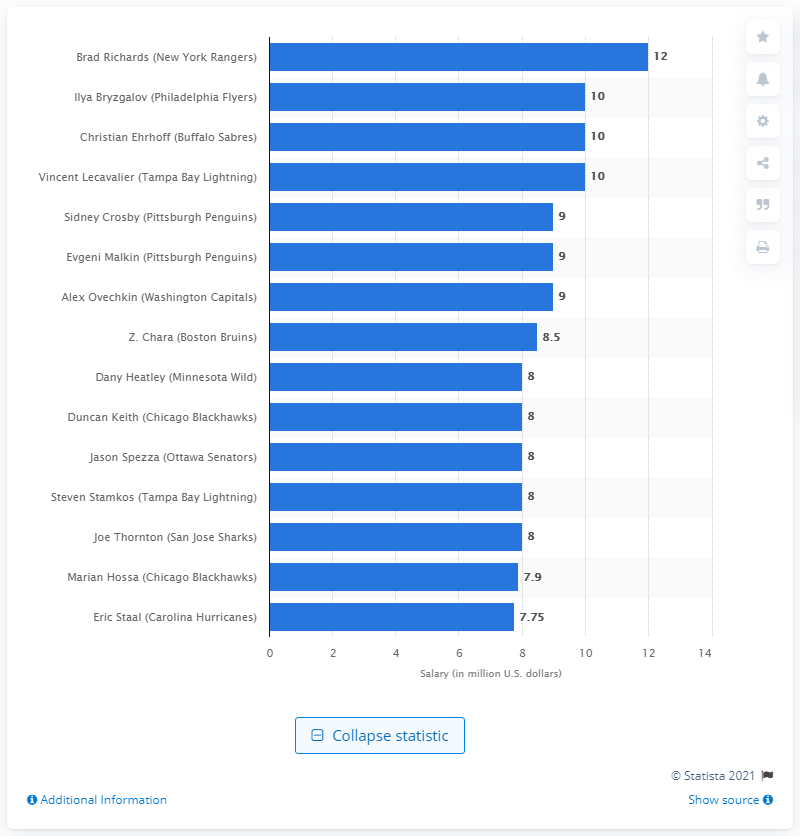Indicate a few pertinent items in this graphic. During the 2011/12 season, Sidney Crosby's salary was approximately $9 million. 